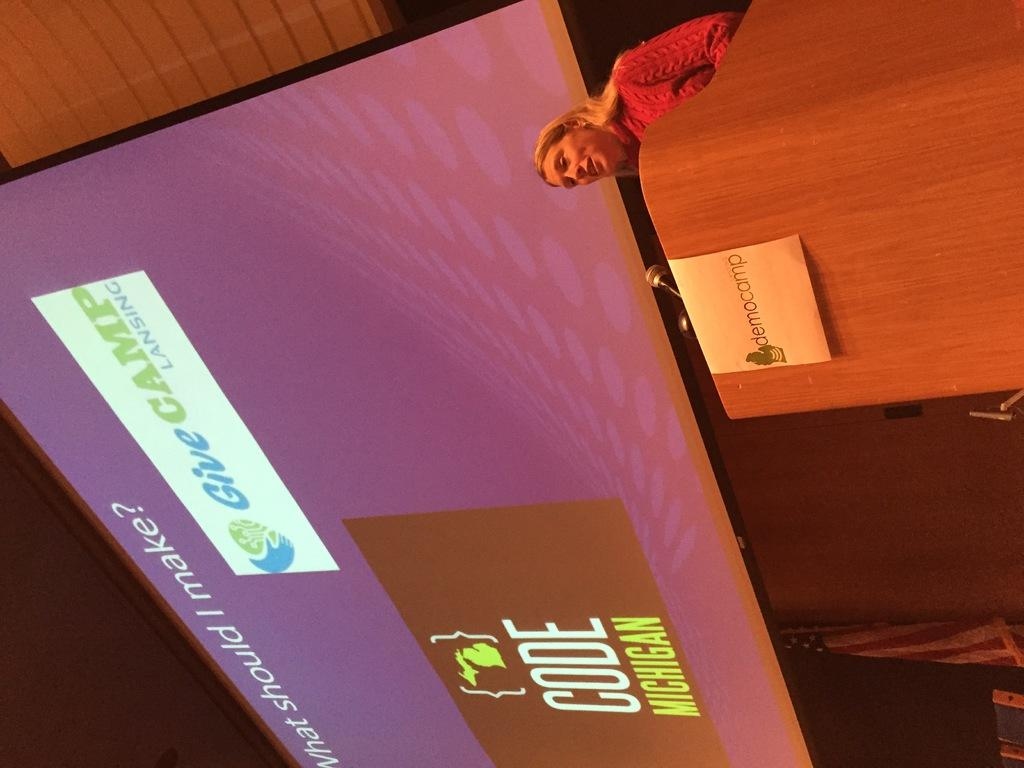What is the woman in the image doing? There is a woman standing in the image, but her activity is not specified. What is in front of the woman in the image? There is a podium in front of the woman. What can be seen in the background of the image? There is a big screen and a flag present in the background of the image. What type of tomatoes are being sold in the alley behind the woman in the image? There is no alley or tomatoes present in the image. Is the woman in the image standing next to a crib? There is no crib present in the image. 